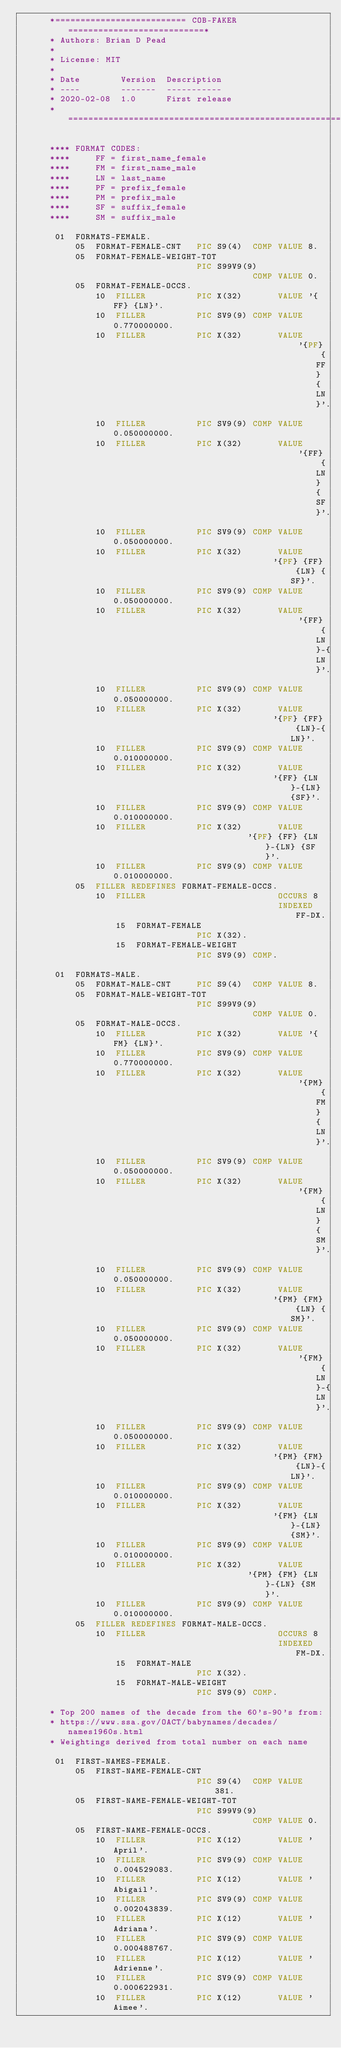Convert code to text. <code><loc_0><loc_0><loc_500><loc_500><_COBOL_>      *========================== COB-FAKER ===========================*
      * Authors: Brian D Pead
      *
      * License: MIT
      *
      * Date        Version  Description
      * ----        -------  -----------
      * 2020-02-08  1.0      First release
      *================================================================*

      **** FORMAT CODES:
      ****     FF = first_name_female
      ****     FM = first_name_male
      ****     LN = last_name
      ****     PF = prefix_female
      ****     PM = prefix_male
      ****     SF = suffix_female
      ****     SM = suffix_male

       01  FORMATS-FEMALE.
           05  FORMAT-FEMALE-CNT   PIC S9(4)  COMP VALUE 8.
           05  FORMAT-FEMALE-WEIGHT-TOT
                                   PIC S99V9(9)
                                              COMP VALUE 0.
           05  FORMAT-FEMALE-OCCS.
               10  FILLER          PIC X(32)       VALUE '{FF} {LN}'.
               10  FILLER          PIC SV9(9) COMP VALUE  0.770000000.
               10  FILLER          PIC X(32)       VALUE 
                                                       '{PF} {FF} {LN}'.
               10  FILLER          PIC SV9(9) COMP VALUE  0.050000000.
               10  FILLER          PIC X(32)       VALUE
                                                       '{FF} {LN} {SF}'.
               10  FILLER          PIC SV9(9) COMP VALUE  0.050000000.
               10  FILLER          PIC X(32)       VALUE 
                                                  '{PF} {FF} {LN} {SF}'.
               10  FILLER          PIC SV9(9) COMP VALUE  0.050000000.
               10  FILLER          PIC X(32)       VALUE 
                                                       '{FF} {LN}-{LN}'.
               10  FILLER          PIC SV9(9) COMP VALUE  0.050000000.
               10  FILLER          PIC X(32)       VALUE 
                                                  '{PF} {FF} {LN}-{LN}'.
               10  FILLER          PIC SV9(9) COMP VALUE  0.010000000.
               10  FILLER          PIC X(32)       VALUE
                                                  '{FF} {LN}-{LN} {SF}'.
               10  FILLER          PIC SV9(9) COMP VALUE  0.010000000.
               10  FILLER          PIC X(32)       VALUE 
                                             '{PF} {FF} {LN}-{LN} {SF}'.
               10  FILLER          PIC SV9(9) COMP VALUE  0.010000000.
           05  FILLER REDEFINES FORMAT-FEMALE-OCCS.
               10  FILLER                          OCCURS 8
                                                   INDEXED FF-DX.
                   15  FORMAT-FEMALE 
                                   PIC X(32).
                   15  FORMAT-FEMALE-WEIGHT
                                   PIC SV9(9) COMP.

       01  FORMATS-MALE.
           05  FORMAT-MALE-CNT     PIC S9(4)  COMP VALUE 8.
           05  FORMAT-MALE-WEIGHT-TOT
                                   PIC S99V9(9)
                                              COMP VALUE 0.
           05  FORMAT-MALE-OCCS.
               10  FILLER          PIC X(32)       VALUE '{FM} {LN}'.
               10  FILLER          PIC SV9(9) COMP VALUE  0.770000000.
               10  FILLER          PIC X(32)       VALUE 
                                                       '{PM} {FM} {LN}'.
               10  FILLER          PIC SV9(9) COMP VALUE  0.050000000.
               10  FILLER          PIC X(32)       VALUE
                                                       '{FM} {LN} {SM}'.
               10  FILLER          PIC SV9(9) COMP VALUE  0.050000000.
               10  FILLER          PIC X(32)       VALUE 
                                                  '{PM} {FM} {LN} {SM}'.
               10  FILLER          PIC SV9(9) COMP VALUE  0.050000000.
               10  FILLER          PIC X(32)       VALUE 
                                                       '{FM} {LN}-{LN}'.
               10  FILLER          PIC SV9(9) COMP VALUE  0.050000000.
               10  FILLER          PIC X(32)       VALUE 
                                                  '{PM} {FM} {LN}-{LN}'.
               10  FILLER          PIC SV9(9) COMP VALUE  0.010000000.
               10  FILLER          PIC X(32)       VALUE
                                                  '{FM} {LN}-{LN} {SM}'.
               10  FILLER          PIC SV9(9) COMP VALUE  0.010000000.
               10  FILLER          PIC X(32)       VALUE 
                                             '{PM} {FM} {LN}-{LN} {SM}'.
               10  FILLER          PIC SV9(9) COMP VALUE  0.010000000.
           05  FILLER REDEFINES FORMAT-MALE-OCCS.
               10  FILLER                          OCCURS 8
                                                   INDEXED FM-DX.
                   15  FORMAT-MALE 
                                   PIC X(32).
                   15  FORMAT-MALE-WEIGHT
                                   PIC SV9(9) COMP.

      * Top 200 names of the decade from the 60's-90's from:
      * https://www.ssa.gov/OACT/babynames/decades/names1960s.html
      * Weightings derived from total number on each name

       01  FIRST-NAMES-FEMALE.
           05  FIRST-NAME-FEMALE-CNT
                                   PIC S9(4)  COMP VALUE 381.
           05  FIRST-NAME-FEMALE-WEIGHT-TOT
                                   PIC S99V9(9)
                                              COMP VALUE 0.
           05  FIRST-NAME-FEMALE-OCCS.
               10  FILLER          PIC X(12)       VALUE 'April'.
               10  FILLER          PIC SV9(9) COMP VALUE  0.004529083.
               10  FILLER          PIC X(12)       VALUE 'Abigail'.
               10  FILLER          PIC SV9(9) COMP VALUE  0.002043839.
               10  FILLER          PIC X(12)       VALUE 'Adriana'.
               10  FILLER          PIC SV9(9) COMP VALUE  0.000488767.
               10  FILLER          PIC X(12)       VALUE 'Adrienne'.
               10  FILLER          PIC SV9(9) COMP VALUE  0.000622931.
               10  FILLER          PIC X(12)       VALUE 'Aimee'.</code> 